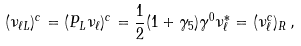<formula> <loc_0><loc_0><loc_500><loc_500>( \nu _ { \ell L } ) ^ { c } = ( P _ { L } \nu _ { \ell } ) ^ { c } = \frac { 1 } { 2 } ( 1 + \gamma _ { 5 } ) \gamma ^ { 0 } \nu ^ { * } _ { \ell } = ( \nu ^ { c } _ { \ell } ) _ { R } \, ,</formula> 